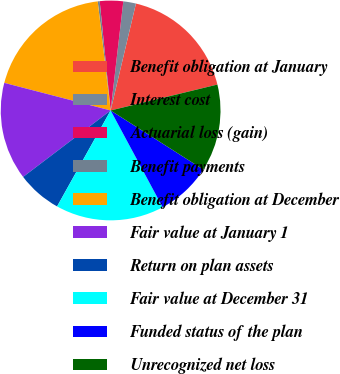Convert chart. <chart><loc_0><loc_0><loc_500><loc_500><pie_chart><fcel>Benefit obligation at January<fcel>Interest cost<fcel>Actuarial loss (gain)<fcel>Benefit payments<fcel>Benefit obligation at December<fcel>Fair value at January 1<fcel>Return on plan assets<fcel>Fair value at December 31<fcel>Funded status of the plan<fcel>Unrecognized net loss<nl><fcel>17.51%<fcel>1.86%<fcel>3.43%<fcel>0.29%<fcel>19.08%<fcel>14.38%<fcel>6.56%<fcel>15.95%<fcel>8.12%<fcel>12.82%<nl></chart> 